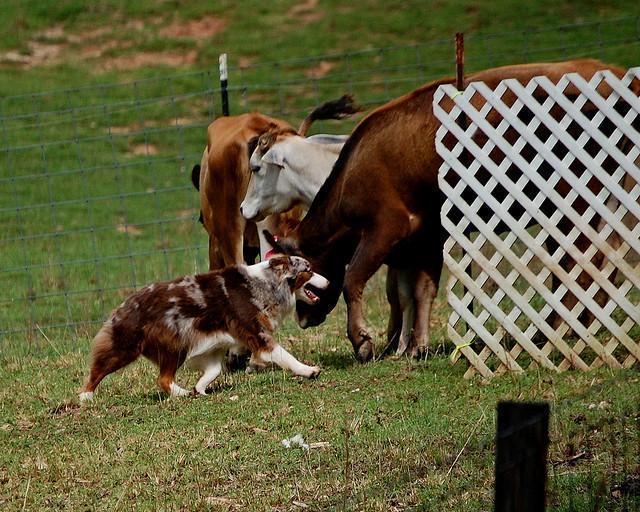What is a male of the larger animals called?
Select the accurate response from the four choices given to answer the question.
Options: Drake, bull, dog, ram. Bull. 